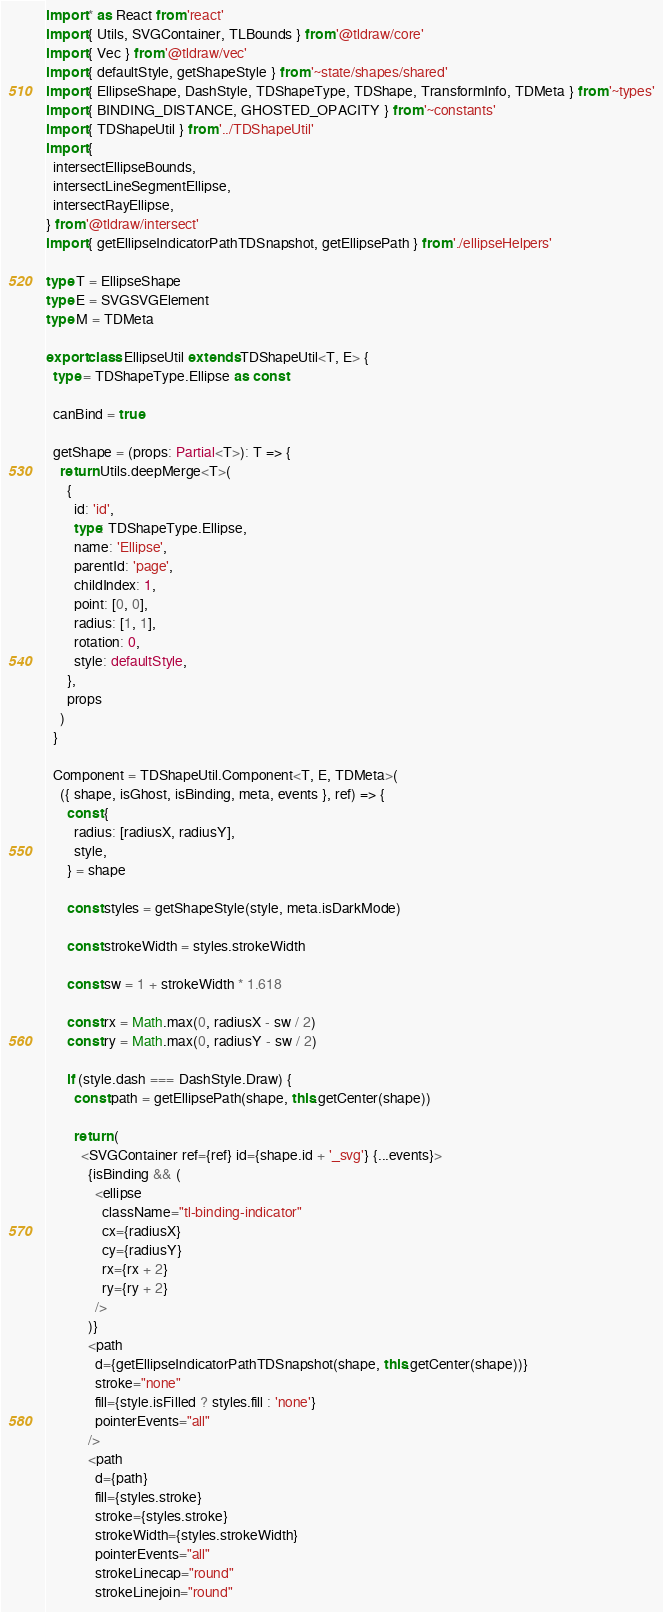<code> <loc_0><loc_0><loc_500><loc_500><_TypeScript_>import * as React from 'react'
import { Utils, SVGContainer, TLBounds } from '@tldraw/core'
import { Vec } from '@tldraw/vec'
import { defaultStyle, getShapeStyle } from '~state/shapes/shared'
import { EllipseShape, DashStyle, TDShapeType, TDShape, TransformInfo, TDMeta } from '~types'
import { BINDING_DISTANCE, GHOSTED_OPACITY } from '~constants'
import { TDShapeUtil } from '../TDShapeUtil'
import {
  intersectEllipseBounds,
  intersectLineSegmentEllipse,
  intersectRayEllipse,
} from '@tldraw/intersect'
import { getEllipseIndicatorPathTDSnapshot, getEllipsePath } from './ellipseHelpers'

type T = EllipseShape
type E = SVGSVGElement
type M = TDMeta

export class EllipseUtil extends TDShapeUtil<T, E> {
  type = TDShapeType.Ellipse as const

  canBind = true

  getShape = (props: Partial<T>): T => {
    return Utils.deepMerge<T>(
      {
        id: 'id',
        type: TDShapeType.Ellipse,
        name: 'Ellipse',
        parentId: 'page',
        childIndex: 1,
        point: [0, 0],
        radius: [1, 1],
        rotation: 0,
        style: defaultStyle,
      },
      props
    )
  }

  Component = TDShapeUtil.Component<T, E, TDMeta>(
    ({ shape, isGhost, isBinding, meta, events }, ref) => {
      const {
        radius: [radiusX, radiusY],
        style,
      } = shape

      const styles = getShapeStyle(style, meta.isDarkMode)

      const strokeWidth = styles.strokeWidth

      const sw = 1 + strokeWidth * 1.618

      const rx = Math.max(0, radiusX - sw / 2)
      const ry = Math.max(0, radiusY - sw / 2)

      if (style.dash === DashStyle.Draw) {
        const path = getEllipsePath(shape, this.getCenter(shape))

        return (
          <SVGContainer ref={ref} id={shape.id + '_svg'} {...events}>
            {isBinding && (
              <ellipse
                className="tl-binding-indicator"
                cx={radiusX}
                cy={radiusY}
                rx={rx + 2}
                ry={ry + 2}
              />
            )}
            <path
              d={getEllipseIndicatorPathTDSnapshot(shape, this.getCenter(shape))}
              stroke="none"
              fill={style.isFilled ? styles.fill : 'none'}
              pointerEvents="all"
            />
            <path
              d={path}
              fill={styles.stroke}
              stroke={styles.stroke}
              strokeWidth={styles.strokeWidth}
              pointerEvents="all"
              strokeLinecap="round"
              strokeLinejoin="round"</code> 